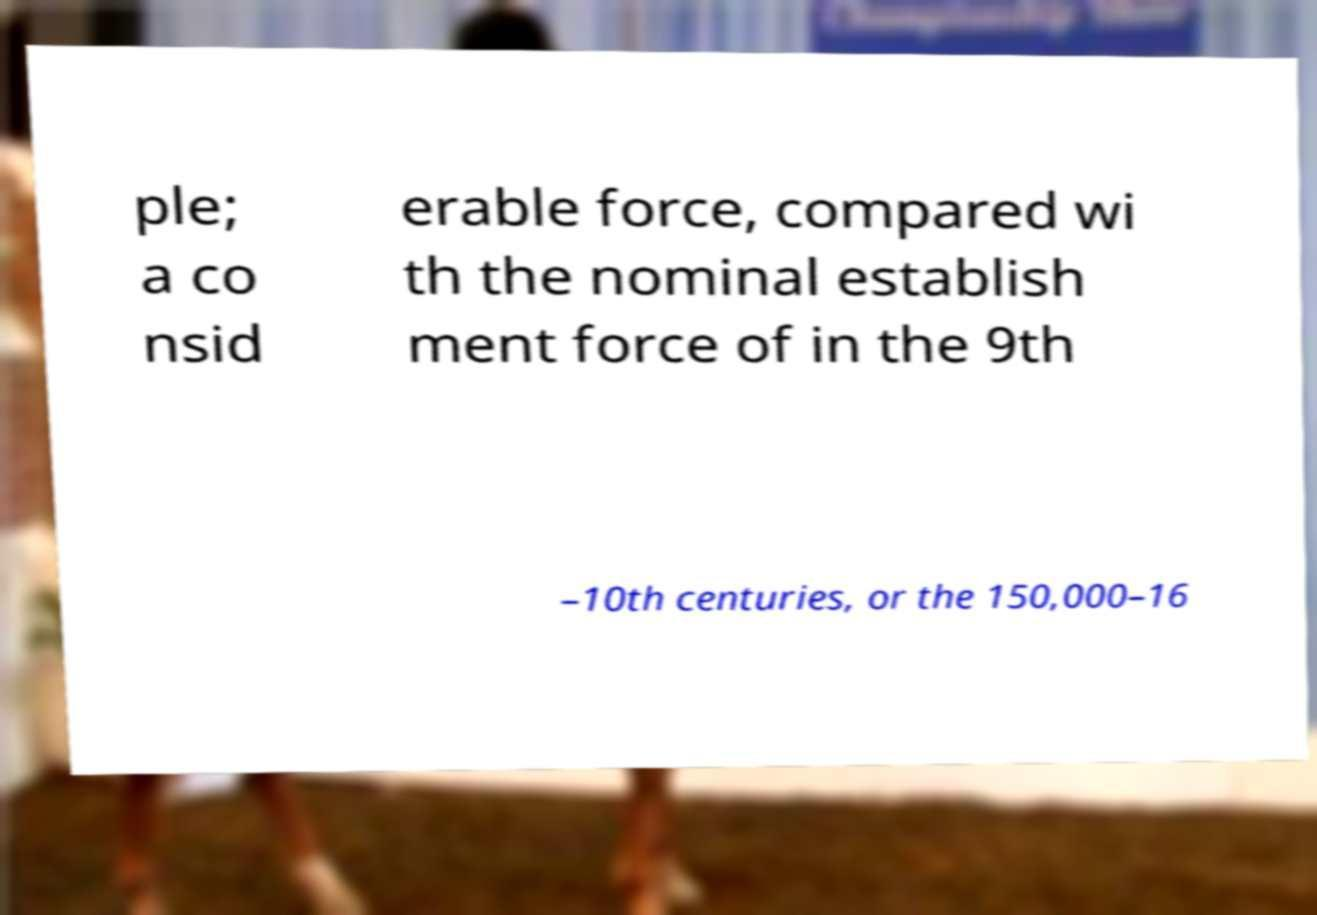What messages or text are displayed in this image? I need them in a readable, typed format. ple; a co nsid erable force, compared wi th the nominal establish ment force of in the 9th –10th centuries, or the 150,000–16 